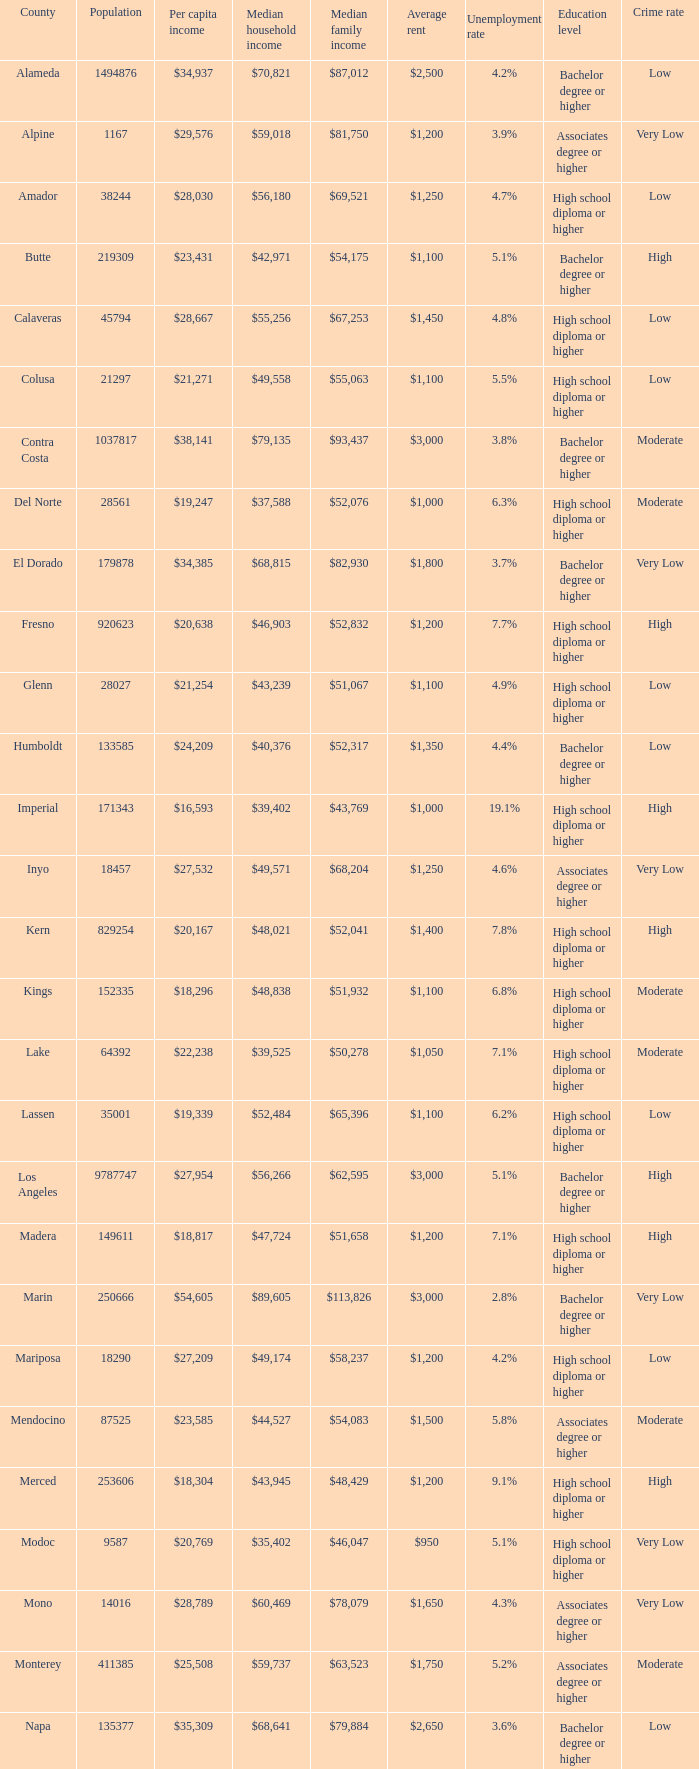In butte, what is the typical income for a household? $42,971. 